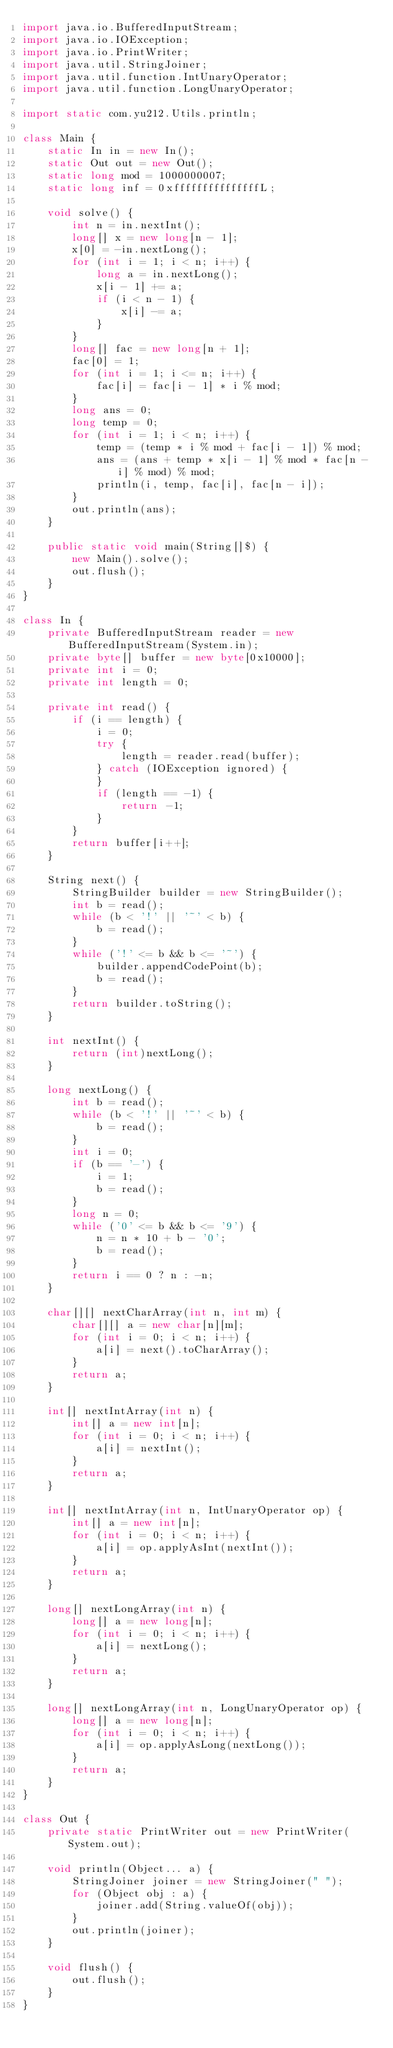<code> <loc_0><loc_0><loc_500><loc_500><_Java_>import java.io.BufferedInputStream;
import java.io.IOException;
import java.io.PrintWriter;
import java.util.StringJoiner;
import java.util.function.IntUnaryOperator;
import java.util.function.LongUnaryOperator;

import static com.yu212.Utils.println;

class Main {
    static In in = new In();
    static Out out = new Out();
    static long mod = 1000000007;
    static long inf = 0xfffffffffffffffL;

    void solve() {
        int n = in.nextInt();
        long[] x = new long[n - 1];
        x[0] = -in.nextLong();
        for (int i = 1; i < n; i++) {
            long a = in.nextLong();
            x[i - 1] += a;
            if (i < n - 1) {
                x[i] -= a;
            }
        }
        long[] fac = new long[n + 1];
        fac[0] = 1;
        for (int i = 1; i <= n; i++) {
            fac[i] = fac[i - 1] * i % mod;
        }
        long ans = 0;
        long temp = 0;
        for (int i = 1; i < n; i++) {
            temp = (temp * i % mod + fac[i - 1]) % mod;
            ans = (ans + temp * x[i - 1] % mod * fac[n - i] % mod) % mod;
            println(i, temp, fac[i], fac[n - i]);
        }
        out.println(ans);
    }

    public static void main(String[]$) {
        new Main().solve();
        out.flush();
    }
}

class In {
    private BufferedInputStream reader = new BufferedInputStream(System.in);
    private byte[] buffer = new byte[0x10000];
    private int i = 0;
    private int length = 0;

    private int read() {
        if (i == length) {
            i = 0;
            try {
                length = reader.read(buffer);
            } catch (IOException ignored) {
            }
            if (length == -1) {
                return -1;
            }
        }
        return buffer[i++];
    }

    String next() {
        StringBuilder builder = new StringBuilder();
        int b = read();
        while (b < '!' || '~' < b) {
            b = read();
        }
        while ('!' <= b && b <= '~') {
            builder.appendCodePoint(b);
            b = read();
        }
        return builder.toString();
    }

    int nextInt() {
        return (int)nextLong();
    }

    long nextLong() {
        int b = read();
        while (b < '!' || '~' < b) {
            b = read();
        }
        int i = 0;
        if (b == '-') {
            i = 1;
            b = read();
        }
        long n = 0;
        while ('0' <= b && b <= '9') {
            n = n * 10 + b - '0';
            b = read();
        }
        return i == 0 ? n : -n;
    }

    char[][] nextCharArray(int n, int m) {
        char[][] a = new char[n][m];
        for (int i = 0; i < n; i++) {
            a[i] = next().toCharArray();
        }
        return a;
    }

    int[] nextIntArray(int n) {
        int[] a = new int[n];
        for (int i = 0; i < n; i++) {
            a[i] = nextInt();
        }
        return a;
    }

    int[] nextIntArray(int n, IntUnaryOperator op) {
        int[] a = new int[n];
        for (int i = 0; i < n; i++) {
            a[i] = op.applyAsInt(nextInt());
        }
        return a;
    }

    long[] nextLongArray(int n) {
        long[] a = new long[n];
        for (int i = 0; i < n; i++) {
            a[i] = nextLong();
        }
        return a;
    }

    long[] nextLongArray(int n, LongUnaryOperator op) {
        long[] a = new long[n];
        for (int i = 0; i < n; i++) {
            a[i] = op.applyAsLong(nextLong());
        }
        return a;
    }
}

class Out {
    private static PrintWriter out = new PrintWriter(System.out);

    void println(Object... a) {
        StringJoiner joiner = new StringJoiner(" ");
        for (Object obj : a) {
            joiner.add(String.valueOf(obj));
        }
        out.println(joiner);
    }

    void flush() {
        out.flush();
    }
}
</code> 